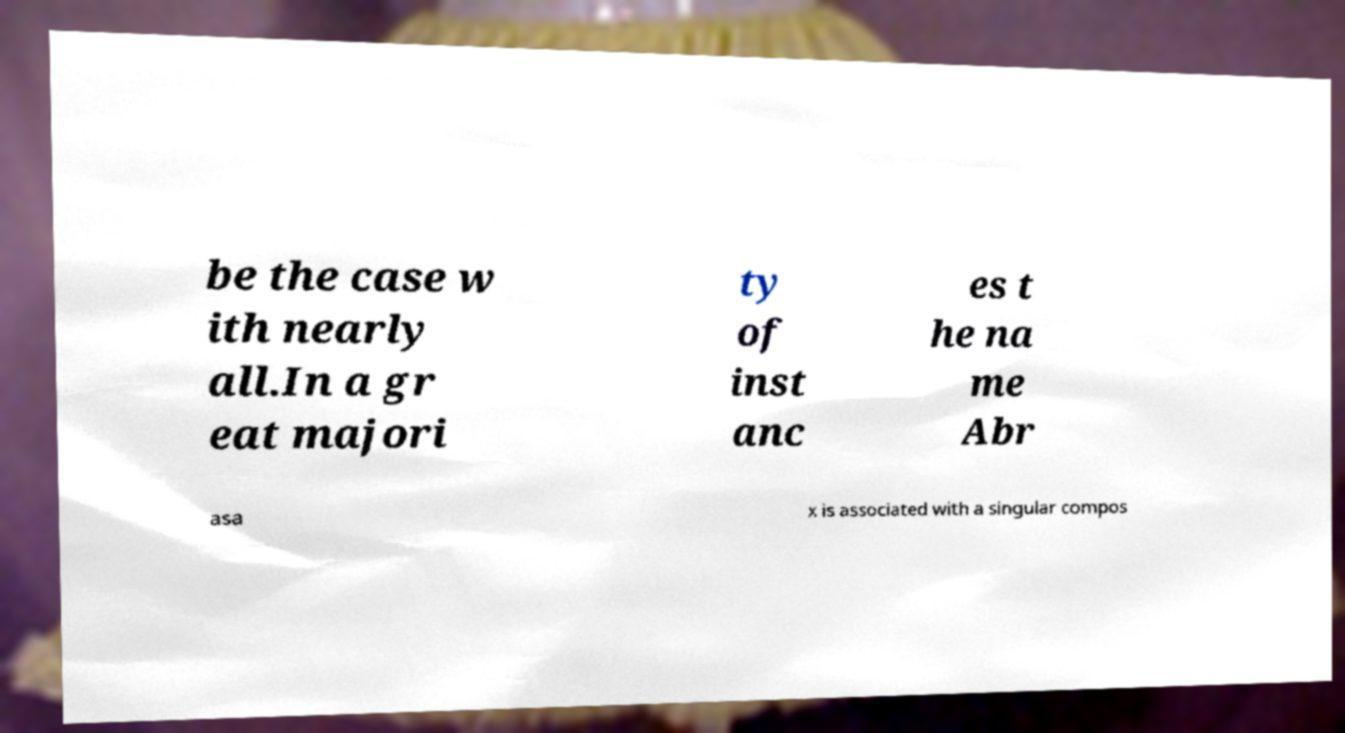What messages or text are displayed in this image? I need them in a readable, typed format. be the case w ith nearly all.In a gr eat majori ty of inst anc es t he na me Abr asa x is associated with a singular compos 